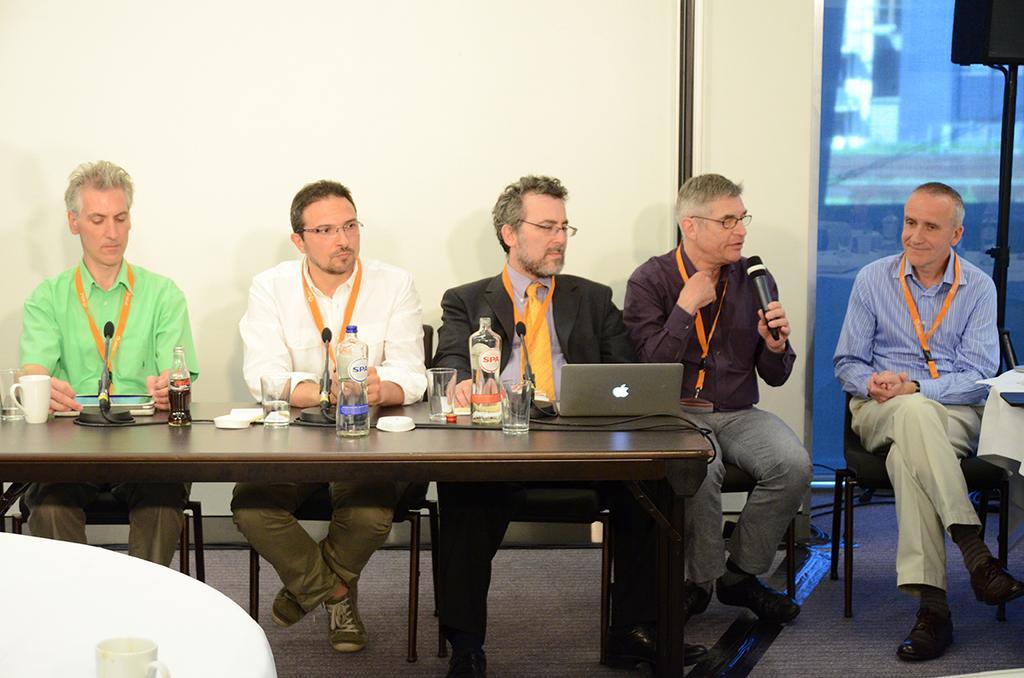Please provide a concise description of this image. In this image i can see five man sitting on chair there is a laptop few bottles, microphone, glasses on the table at the back ground i can see a wall and a glass door. 